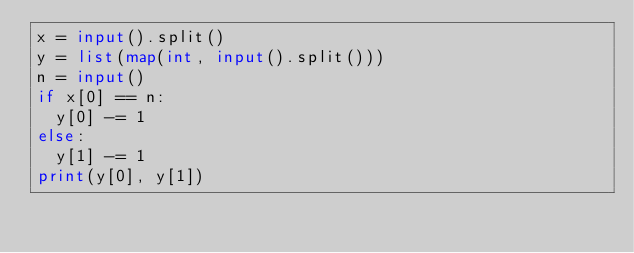Convert code to text. <code><loc_0><loc_0><loc_500><loc_500><_Python_>x = input().split()
y = list(map(int, input().split()))
n = input()
if x[0] == n:
  y[0] -= 1
else:
  y[1] -= 1
print(y[0], y[1])</code> 